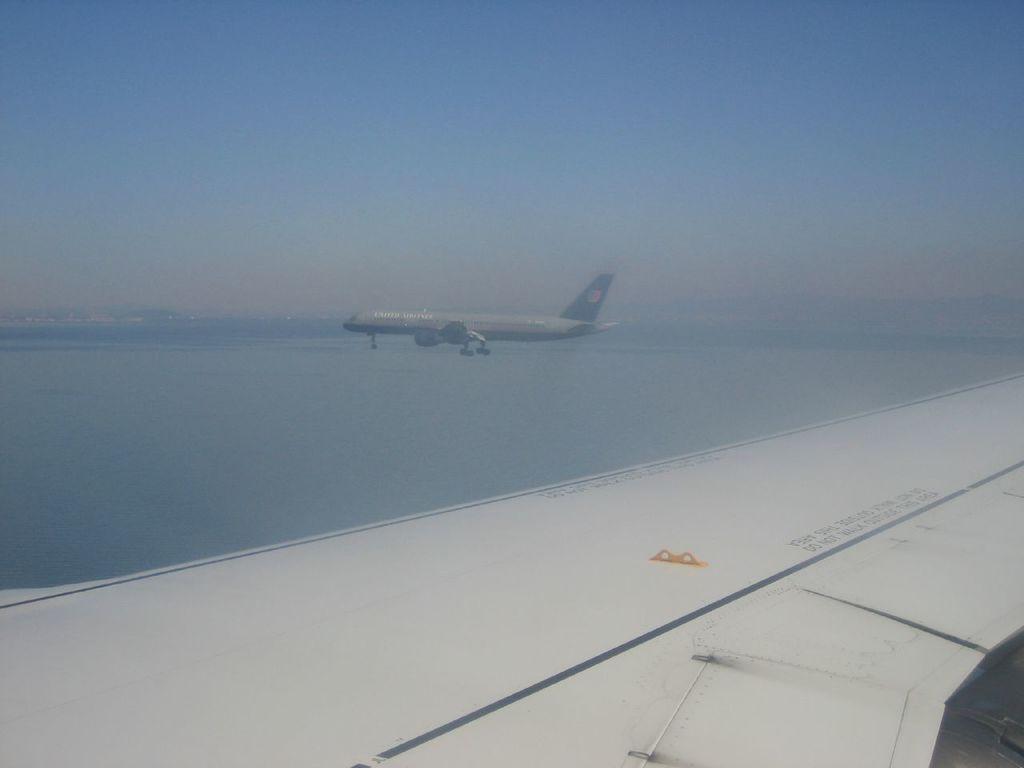Can you describe this image briefly? In this image, we can see an aeroplane. At the bottom, there is a white color. Here we can see some text. Background there is a water and sky. 